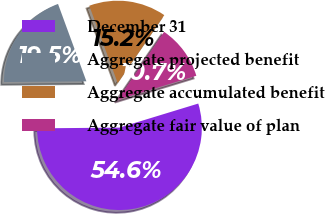Convert chart to OTSL. <chart><loc_0><loc_0><loc_500><loc_500><pie_chart><fcel>December 31<fcel>Aggregate projected benefit<fcel>Aggregate accumulated benefit<fcel>Aggregate fair value of plan<nl><fcel>54.57%<fcel>19.54%<fcel>15.16%<fcel>10.72%<nl></chart> 